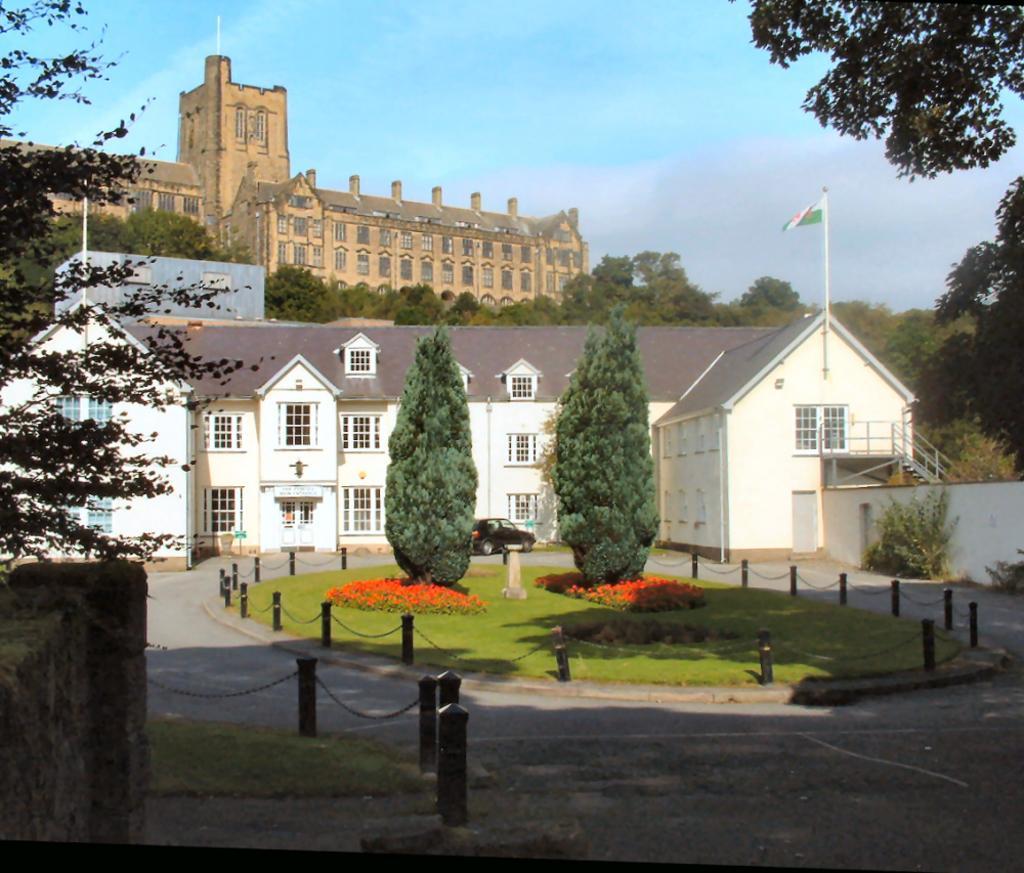In one or two sentences, can you explain what this image depicts? This image is taken outdoors. At the top of the image there is the sky with clouds. At the bottom of the image there is a road. On the left and right sides of the image there are two trees. In the middle of the image there is a building with walls, windows, doors, grills, railings, stairs and roofs. There is a flag and there are a few trees and plants on the ground. There is a rope fence. A car is parked on the ground. In the background there are many trees and there is a building. 